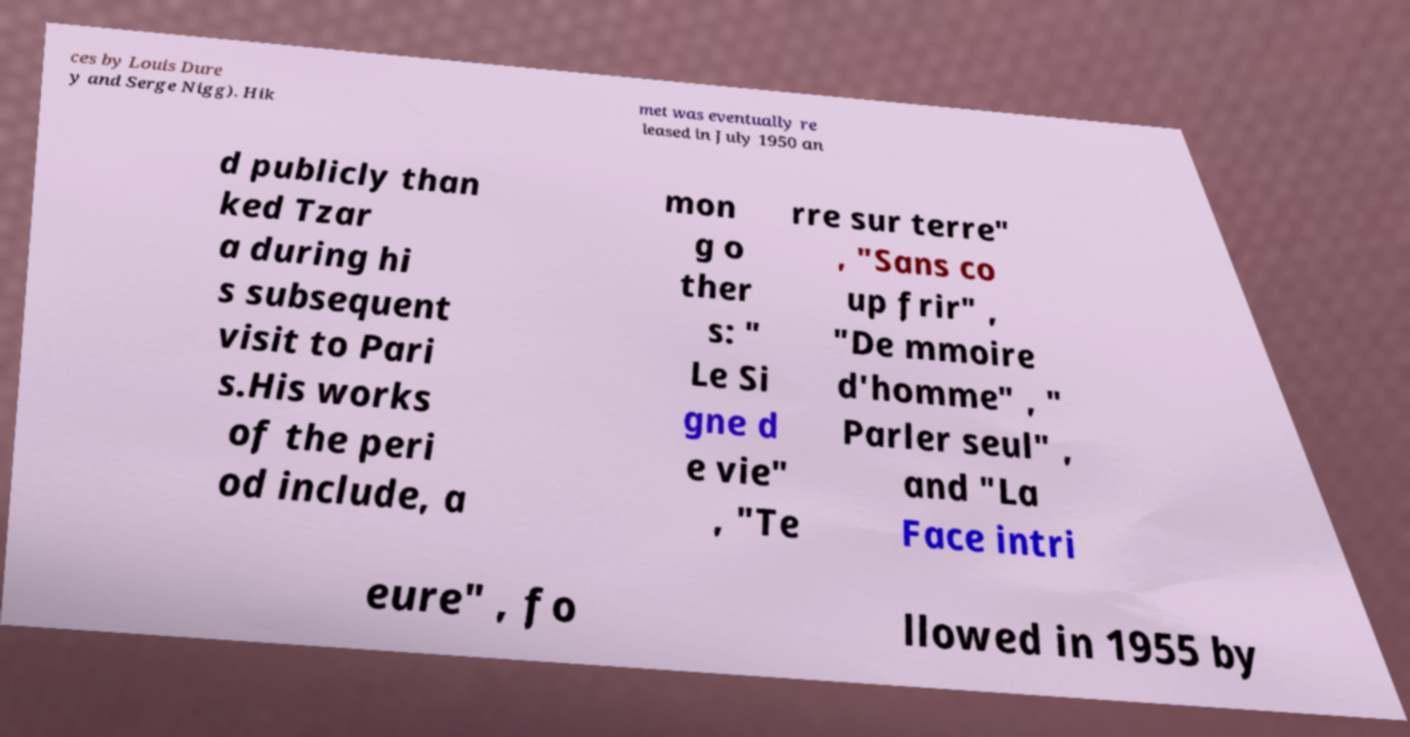Can you accurately transcribe the text from the provided image for me? ces by Louis Dure y and Serge Nigg). Hik met was eventually re leased in July 1950 an d publicly than ked Tzar a during hi s subsequent visit to Pari s.His works of the peri od include, a mon g o ther s: " Le Si gne d e vie" , "Te rre sur terre" , "Sans co up frir" , "De mmoire d'homme" , " Parler seul" , and "La Face intri eure" , fo llowed in 1955 by 